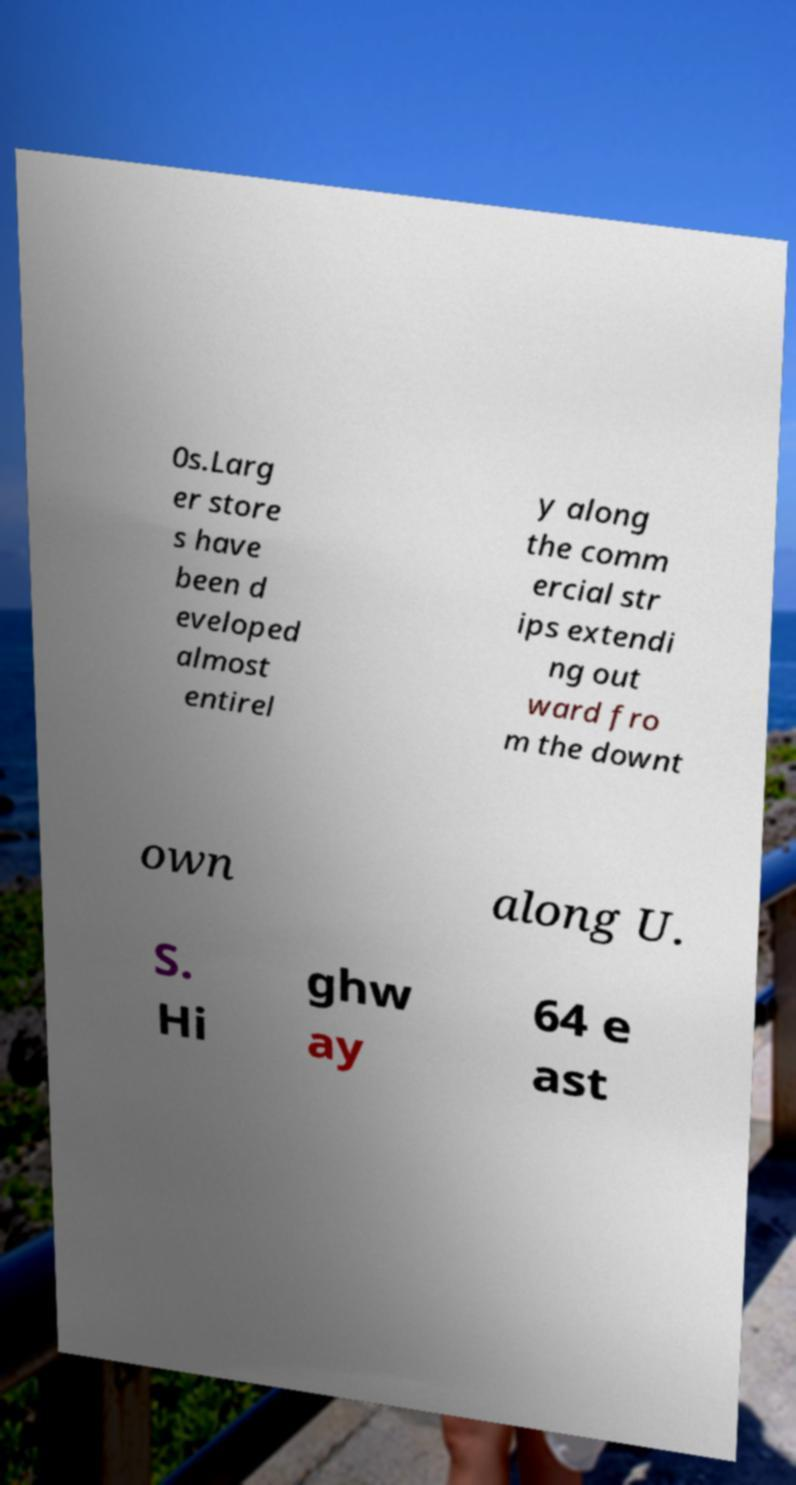Can you read and provide the text displayed in the image?This photo seems to have some interesting text. Can you extract and type it out for me? 0s.Larg er store s have been d eveloped almost entirel y along the comm ercial str ips extendi ng out ward fro m the downt own along U. S. Hi ghw ay 64 e ast 